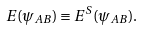Convert formula to latex. <formula><loc_0><loc_0><loc_500><loc_500>E ( \psi _ { A B } ) \equiv E ^ { S } ( \psi _ { A B } ) .</formula> 